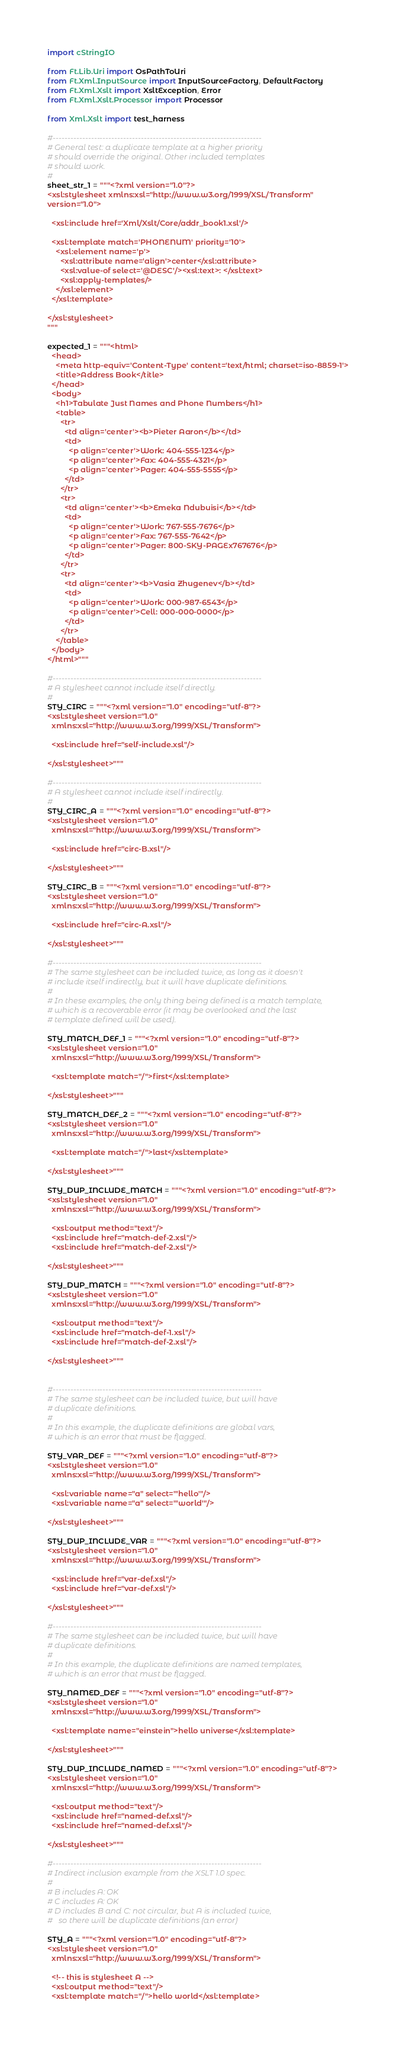<code> <loc_0><loc_0><loc_500><loc_500><_Python_>import cStringIO

from Ft.Lib.Uri import OsPathToUri
from Ft.Xml.InputSource import InputSourceFactory, DefaultFactory
from Ft.Xml.Xslt import XsltException, Error
from Ft.Xml.Xslt.Processor import Processor

from Xml.Xslt import test_harness

#-----------------------------------------------------------------------
# General test: a duplicate template at a higher priority
# should override the original. Other included templates
# should work.
#
sheet_str_1 = """<?xml version="1.0"?>
<xsl:stylesheet xmlns:xsl="http://www.w3.org/1999/XSL/Transform"
version="1.0">

  <xsl:include href='Xml/Xslt/Core/addr_book1.xsl'/>

  <xsl:template match='PHONENUM' priority='10'>
    <xsl:element name='p'>
      <xsl:attribute name='align'>center</xsl:attribute>
      <xsl:value-of select='@DESC'/><xsl:text>: </xsl:text>
      <xsl:apply-templates/>
    </xsl:element>
  </xsl:template>

</xsl:stylesheet>
"""

expected_1 = """<html>
  <head>
    <meta http-equiv='Content-Type' content='text/html; charset=iso-8859-1'>
    <title>Address Book</title>
  </head>
  <body>
    <h1>Tabulate Just Names and Phone Numbers</h1>
    <table>
      <tr>
        <td align='center'><b>Pieter Aaron</b></td>
        <td>
          <p align='center'>Work: 404-555-1234</p>
          <p align='center'>Fax: 404-555-4321</p>
          <p align='center'>Pager: 404-555-5555</p>
        </td>
      </tr>
      <tr>
        <td align='center'><b>Emeka Ndubuisi</b></td>
        <td>
          <p align='center'>Work: 767-555-7676</p>
          <p align='center'>Fax: 767-555-7642</p>
          <p align='center'>Pager: 800-SKY-PAGEx767676</p>
        </td>
      </tr>
      <tr>
        <td align='center'><b>Vasia Zhugenev</b></td>
        <td>
          <p align='center'>Work: 000-987-6543</p>
          <p align='center'>Cell: 000-000-0000</p>
        </td>
      </tr>
    </table>
  </body>
</html>"""

#-----------------------------------------------------------------------
# A stylesheet cannot include itself directly.
#
STY_CIRC = """<?xml version="1.0" encoding="utf-8"?>
<xsl:stylesheet version="1.0"
  xmlns:xsl="http://www.w3.org/1999/XSL/Transform">

  <xsl:include href="self-include.xsl"/>

</xsl:stylesheet>"""

#-----------------------------------------------------------------------
# A stylesheet cannot include itself indirectly.
#
STY_CIRC_A = """<?xml version="1.0" encoding="utf-8"?>
<xsl:stylesheet version="1.0"
  xmlns:xsl="http://www.w3.org/1999/XSL/Transform">

  <xsl:include href="circ-B.xsl"/>

</xsl:stylesheet>"""

STY_CIRC_B = """<?xml version="1.0" encoding="utf-8"?>
<xsl:stylesheet version="1.0"
  xmlns:xsl="http://www.w3.org/1999/XSL/Transform">

  <xsl:include href="circ-A.xsl"/>

</xsl:stylesheet>"""

#-----------------------------------------------------------------------
# The same stylesheet can be included twice, as long as it doesn't
# include itself indirectly, but it will have duplicate definitions.
#
# In these examples, the only thing being defined is a match template,
# which is a recoverable error (it may be overlooked and the last
# template defined will be used).

STY_MATCH_DEF_1 = """<?xml version="1.0" encoding="utf-8"?>
<xsl:stylesheet version="1.0"
  xmlns:xsl="http://www.w3.org/1999/XSL/Transform">

  <xsl:template match="/">first</xsl:template>

</xsl:stylesheet>"""

STY_MATCH_DEF_2 = """<?xml version="1.0" encoding="utf-8"?>
<xsl:stylesheet version="1.0"
  xmlns:xsl="http://www.w3.org/1999/XSL/Transform">

  <xsl:template match="/">last</xsl:template>

</xsl:stylesheet>"""

STY_DUP_INCLUDE_MATCH = """<?xml version="1.0" encoding="utf-8"?>
<xsl:stylesheet version="1.0"
  xmlns:xsl="http://www.w3.org/1999/XSL/Transform">

  <xsl:output method="text"/>
  <xsl:include href="match-def-2.xsl"/>
  <xsl:include href="match-def-2.xsl"/>

</xsl:stylesheet>"""

STY_DUP_MATCH = """<?xml version="1.0" encoding="utf-8"?>
<xsl:stylesheet version="1.0"
  xmlns:xsl="http://www.w3.org/1999/XSL/Transform">

  <xsl:output method="text"/>
  <xsl:include href="match-def-1.xsl"/>
  <xsl:include href="match-def-2.xsl"/>

</xsl:stylesheet>"""


#-----------------------------------------------------------------------
# The same stylesheet can be included twice, but will have
# duplicate definitions.
#
# In this example, the duplicate definitions are global vars,
# which is an error that must be flagged.

STY_VAR_DEF = """<?xml version="1.0" encoding="utf-8"?>
<xsl:stylesheet version="1.0"
  xmlns:xsl="http://www.w3.org/1999/XSL/Transform">

  <xsl:variable name="a" select="'hello'"/>
  <xsl:variable name="a" select="'world'"/>

</xsl:stylesheet>"""

STY_DUP_INCLUDE_VAR = """<?xml version="1.0" encoding="utf-8"?>
<xsl:stylesheet version="1.0"
  xmlns:xsl="http://www.w3.org/1999/XSL/Transform">

  <xsl:include href="var-def.xsl"/>
  <xsl:include href="var-def.xsl"/>

</xsl:stylesheet>"""

#-----------------------------------------------------------------------
# The same stylesheet can be included twice, but will have
# duplicate definitions.
#
# In this example, the duplicate definitions are named templates,
# which is an error that must be flagged.

STY_NAMED_DEF = """<?xml version="1.0" encoding="utf-8"?>
<xsl:stylesheet version="1.0"
  xmlns:xsl="http://www.w3.org/1999/XSL/Transform">

  <xsl:template name="einstein">hello universe</xsl:template>

</xsl:stylesheet>"""

STY_DUP_INCLUDE_NAMED = """<?xml version="1.0" encoding="utf-8"?>
<xsl:stylesheet version="1.0"
  xmlns:xsl="http://www.w3.org/1999/XSL/Transform">

  <xsl:output method="text"/>
  <xsl:include href="named-def.xsl"/>
  <xsl:include href="named-def.xsl"/>

</xsl:stylesheet>"""

#-----------------------------------------------------------------------
# Indirect inclusion example from the XSLT 1.0 spec.
#
# B includes A: OK
# C includes A: OK
# D includes B and C: not circular, but A is included twice,
#   so there will be duplicate definitions (an error)

STY_A = """<?xml version="1.0" encoding="utf-8"?>
<xsl:stylesheet version="1.0"
  xmlns:xsl="http://www.w3.org/1999/XSL/Transform">

  <!-- this is stylesheet A -->
  <xsl:output method="text"/>
  <xsl:template match="/">hello world</xsl:template>
</code> 